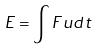<formula> <loc_0><loc_0><loc_500><loc_500>E = \int F u d t</formula> 